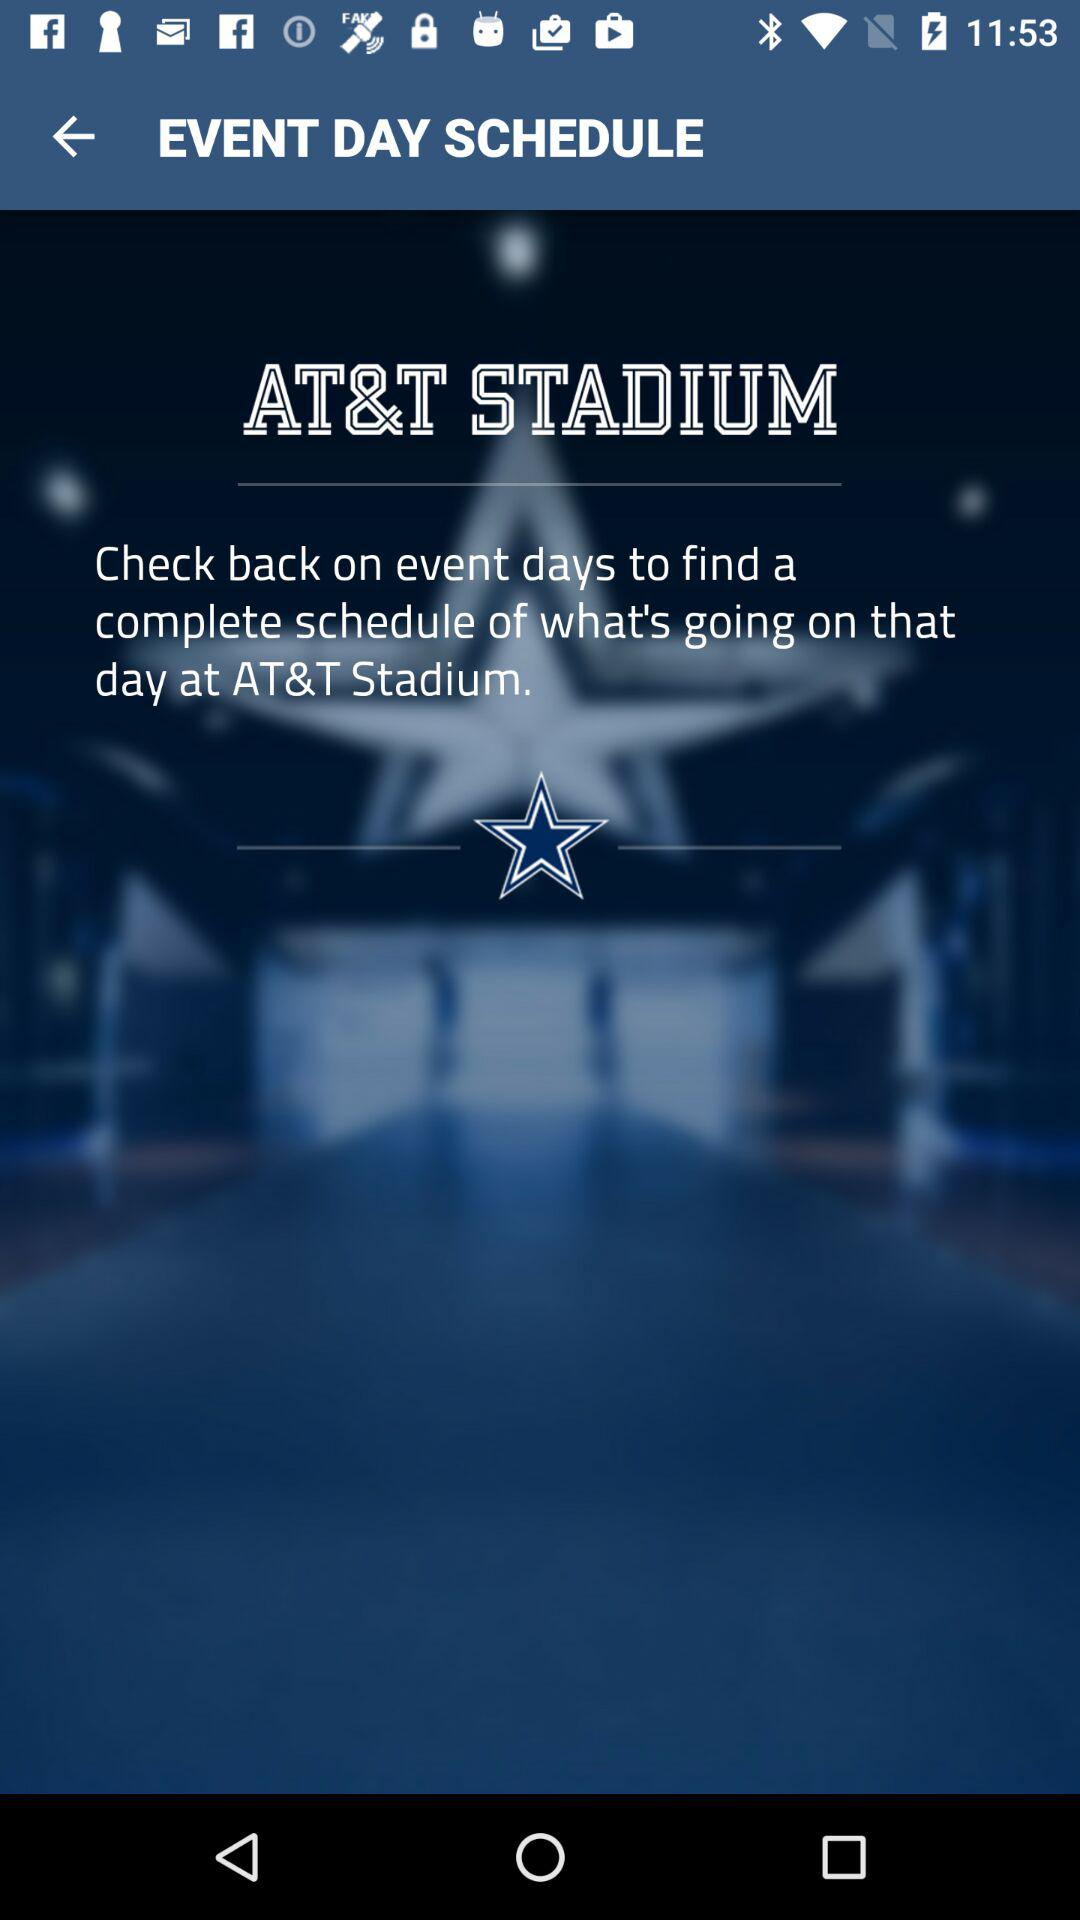What stadium name is displayed? The stadium name is "AT&T STADIUM". 